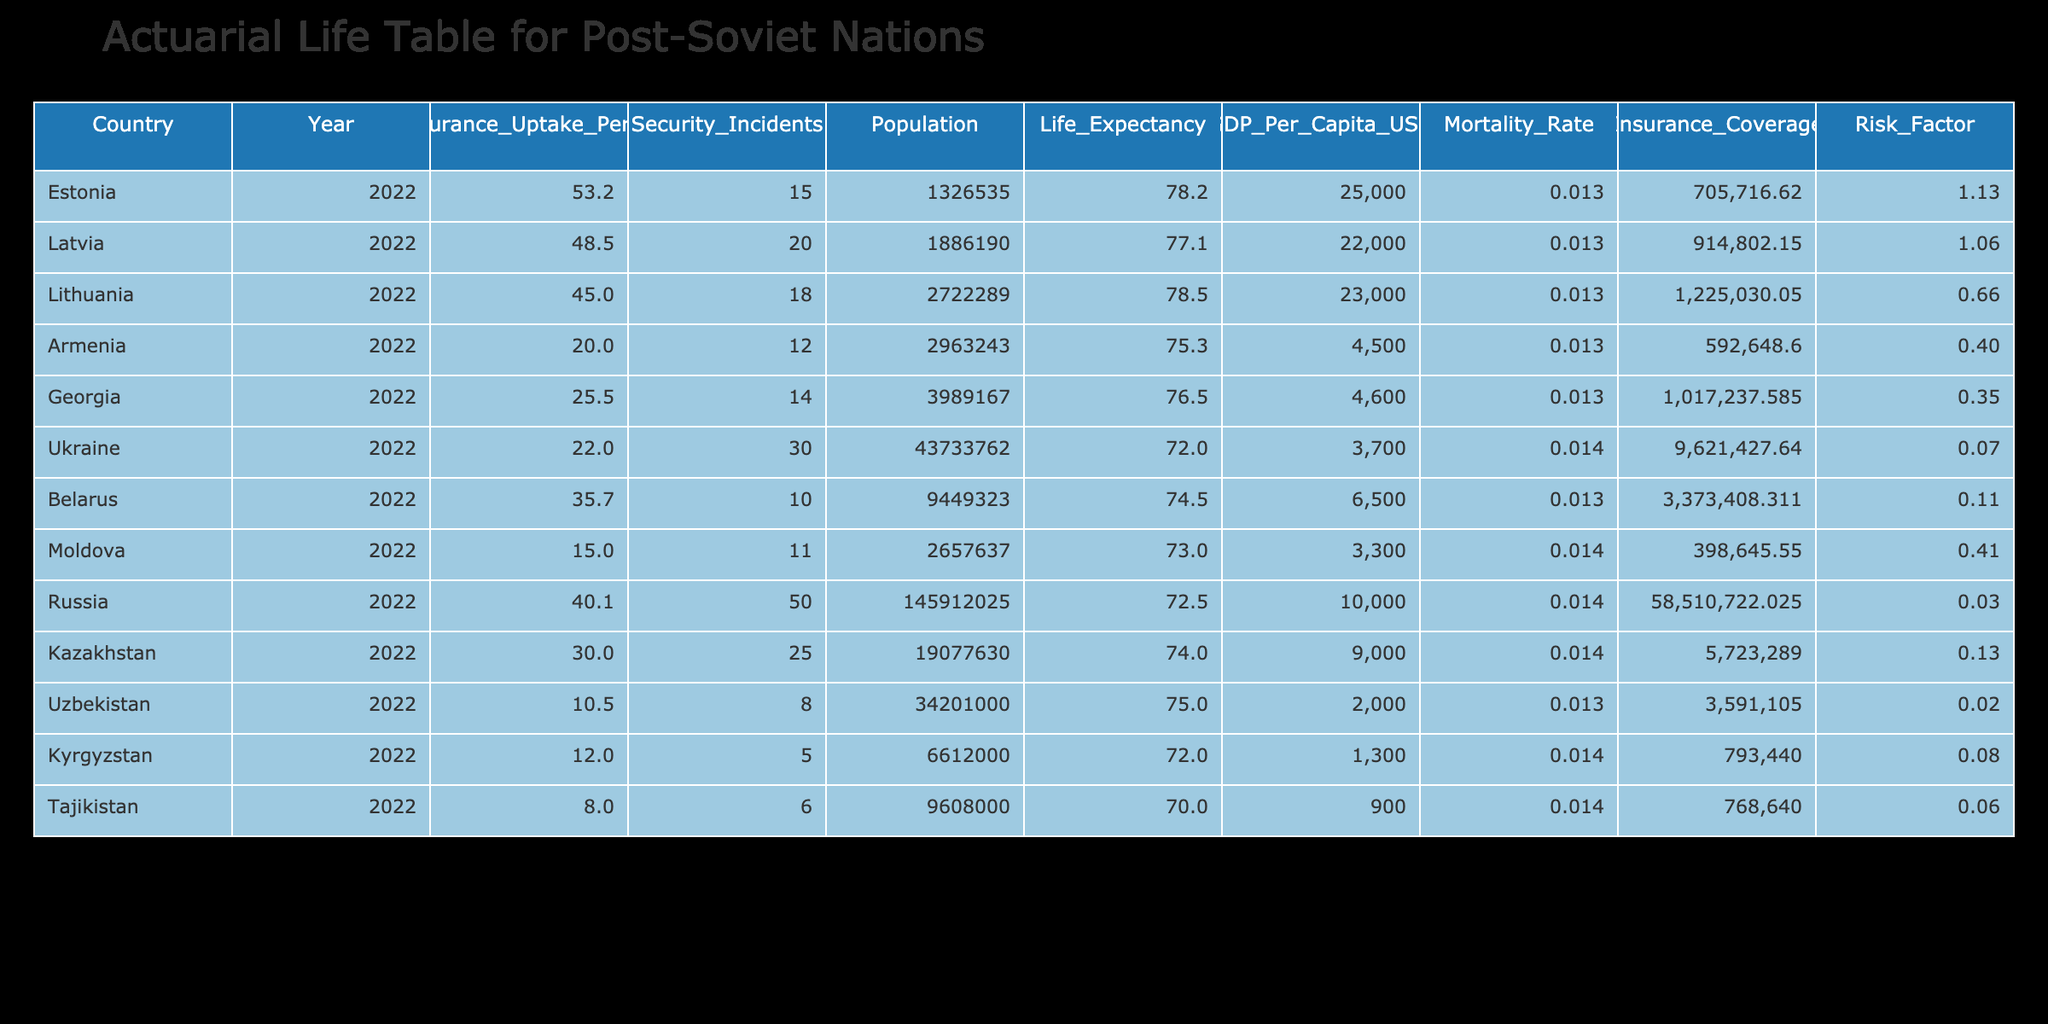What is the life insurance uptake percentage in Ukraine? The table indicates that the life insurance uptake percentage for Ukraine in 2022 is 22.0.
Answer: 22.0 Which country has the highest life expectancy? The life expectancy column shows that Estonia has the highest life expectancy at 78.2 years.
Answer: Estonia How many security incidents were recorded in Kazakhstan? According to the table, Kazakhstan experienced 25 security incidents in the year 2022.
Answer: 25 What is the average GDP per capita of the countries listed? The GDP per capita values are summed up to give (25000 + 22000 + 23000 + 4500 + 4600 + 3700 + 6500 + 3300 + 10000 + 9000 + 2000 + 1300 + 900) = 102000, and there are 13 countries. The average is 102000/13 = 7846.15.
Answer: 7846.15 Does Moldova have a higher life insurance uptake percentage than Uzbekistan? Moldova has a life insurance uptake percentage of 15.0, while Uzbekistan has 10.5, which means Moldova does have a higher percentage.
Answer: Yes What is the relationship between life insurance uptake and security incidents based on the data? Examining the table, as security incidents increase, we can see that most countries with higher incidents tend to have lower life insurance uptake percentages, such as Ukraine and Russia, indicating a potential negative correlation.
Answer: Negative correlation What is the total population of the countries listed in the table? By summing the populations (1,326,535 + 1,886,190 + 2,722,289 + 2,963,243 + 3,989,167 + 43,733,762 + 9,449,323 + 2,657,637 + 145,912,025 + 19,077,630 + 34,201,000 + 6,612,000 + 9,608,000), the total population is 234,678,945.
Answer: 234,678,945 Which country has the lowest life expectancy? According to the life expectancy column, Tajikistan has the lowest life expectancy at 70.0 years.
Answer: Tajikistan Is there a country where life insurance uptake is more than 50%? The data shows that no country listed has a life insurance uptake percentage exceeding 50% in 2022.
Answer: No If you combine the life insurance uptake percentages of the top three countries, what is the total? The total for the top three countries can be calculated as 53.2 (Estonia) + 48.5 (Latvia) + 45.0 (Lithuania) = 146.7.
Answer: 146.7 